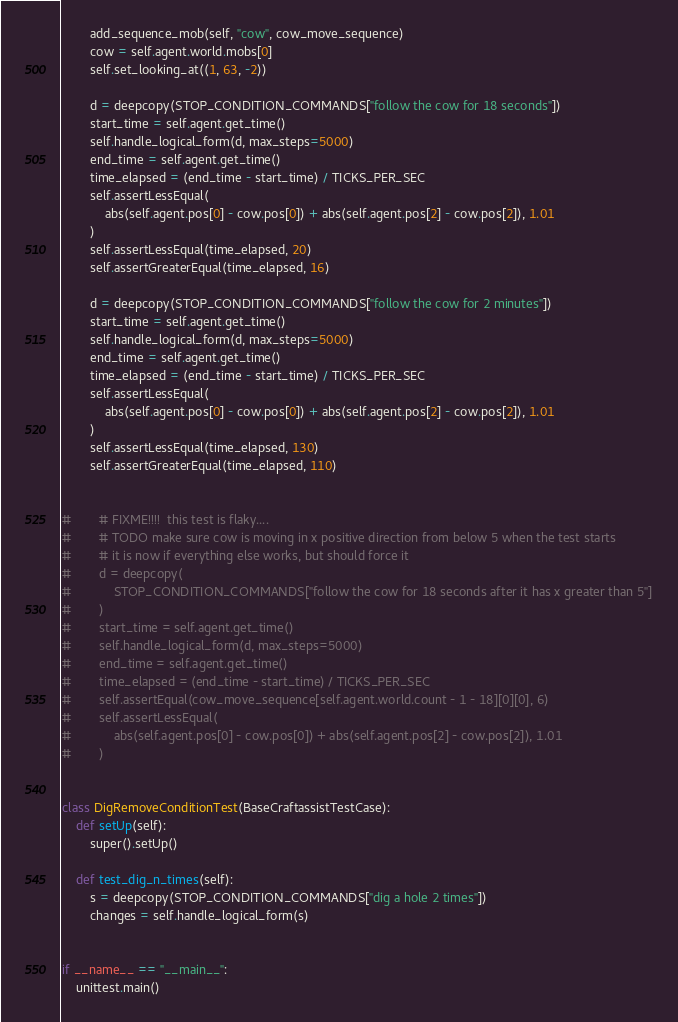Convert code to text. <code><loc_0><loc_0><loc_500><loc_500><_Python_>        add_sequence_mob(self, "cow", cow_move_sequence)
        cow = self.agent.world.mobs[0]
        self.set_looking_at((1, 63, -2))

        d = deepcopy(STOP_CONDITION_COMMANDS["follow the cow for 18 seconds"])
        start_time = self.agent.get_time()
        self.handle_logical_form(d, max_steps=5000)
        end_time = self.agent.get_time()
        time_elapsed = (end_time - start_time) / TICKS_PER_SEC
        self.assertLessEqual(
            abs(self.agent.pos[0] - cow.pos[0]) + abs(self.agent.pos[2] - cow.pos[2]), 1.01
        )
        self.assertLessEqual(time_elapsed, 20)
        self.assertGreaterEqual(time_elapsed, 16)

        d = deepcopy(STOP_CONDITION_COMMANDS["follow the cow for 2 minutes"])
        start_time = self.agent.get_time()
        self.handle_logical_form(d, max_steps=5000)
        end_time = self.agent.get_time()
        time_elapsed = (end_time - start_time) / TICKS_PER_SEC
        self.assertLessEqual(
            abs(self.agent.pos[0] - cow.pos[0]) + abs(self.agent.pos[2] - cow.pos[2]), 1.01
        )
        self.assertLessEqual(time_elapsed, 130)
        self.assertGreaterEqual(time_elapsed, 110)


#        # FIXME!!!!  this test is flaky....
#        # TODO make sure cow is moving in x positive direction from below 5 when the test starts
#        # it is now if everything else works, but should force it
#        d = deepcopy(
#            STOP_CONDITION_COMMANDS["follow the cow for 18 seconds after it has x greater than 5"]
#        )
#        start_time = self.agent.get_time()
#        self.handle_logical_form(d, max_steps=5000)
#        end_time = self.agent.get_time()
#        time_elapsed = (end_time - start_time) / TICKS_PER_SEC
#        self.assertEqual(cow_move_sequence[self.agent.world.count - 1 - 18][0][0], 6)
#        self.assertLessEqual(
#            abs(self.agent.pos[0] - cow.pos[0]) + abs(self.agent.pos[2] - cow.pos[2]), 1.01
#        )


class DigRemoveConditionTest(BaseCraftassistTestCase):
    def setUp(self):
        super().setUp()

    def test_dig_n_times(self):
        s = deepcopy(STOP_CONDITION_COMMANDS["dig a hole 2 times"])
        changes = self.handle_logical_form(s)


if __name__ == "__main__":
    unittest.main()
</code> 